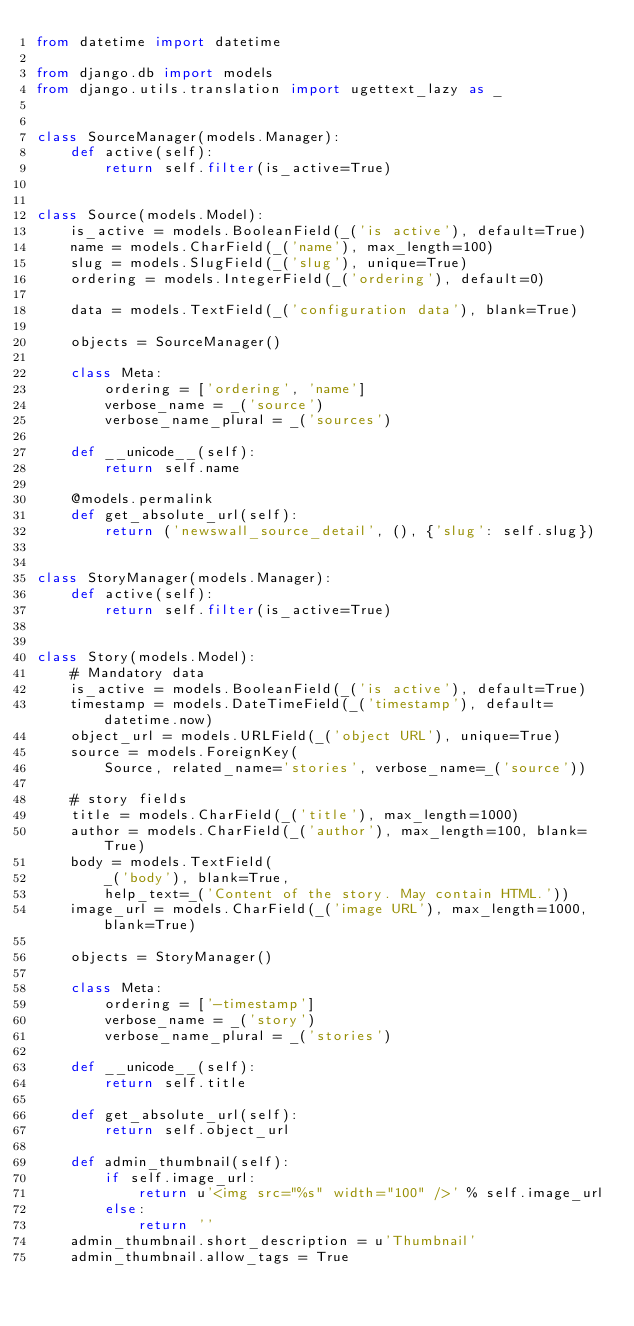<code> <loc_0><loc_0><loc_500><loc_500><_Python_>from datetime import datetime

from django.db import models
from django.utils.translation import ugettext_lazy as _


class SourceManager(models.Manager):
    def active(self):
        return self.filter(is_active=True)


class Source(models.Model):
    is_active = models.BooleanField(_('is active'), default=True)
    name = models.CharField(_('name'), max_length=100)
    slug = models.SlugField(_('slug'), unique=True)
    ordering = models.IntegerField(_('ordering'), default=0)

    data = models.TextField(_('configuration data'), blank=True)

    objects = SourceManager()

    class Meta:
        ordering = ['ordering', 'name']
        verbose_name = _('source')
        verbose_name_plural = _('sources')

    def __unicode__(self):
        return self.name

    @models.permalink
    def get_absolute_url(self):
        return ('newswall_source_detail', (), {'slug': self.slug})


class StoryManager(models.Manager):
    def active(self):
        return self.filter(is_active=True)


class Story(models.Model):
    # Mandatory data
    is_active = models.BooleanField(_('is active'), default=True)
    timestamp = models.DateTimeField(_('timestamp'), default=datetime.now)
    object_url = models.URLField(_('object URL'), unique=True)
    source = models.ForeignKey(
        Source, related_name='stories', verbose_name=_('source'))

    # story fields
    title = models.CharField(_('title'), max_length=1000)
    author = models.CharField(_('author'), max_length=100, blank=True)
    body = models.TextField(
        _('body'), blank=True,
        help_text=_('Content of the story. May contain HTML.'))
    image_url = models.CharField(_('image URL'), max_length=1000, blank=True)

    objects = StoryManager()

    class Meta:
        ordering = ['-timestamp']
        verbose_name = _('story')
        verbose_name_plural = _('stories')

    def __unicode__(self):
        return self.title

    def get_absolute_url(self):
        return self.object_url

    def admin_thumbnail(self):
        if self.image_url:
            return u'<img src="%s" width="100" />' % self.image_url
        else:
            return ''
    admin_thumbnail.short_description = u'Thumbnail'
    admin_thumbnail.allow_tags = True
</code> 